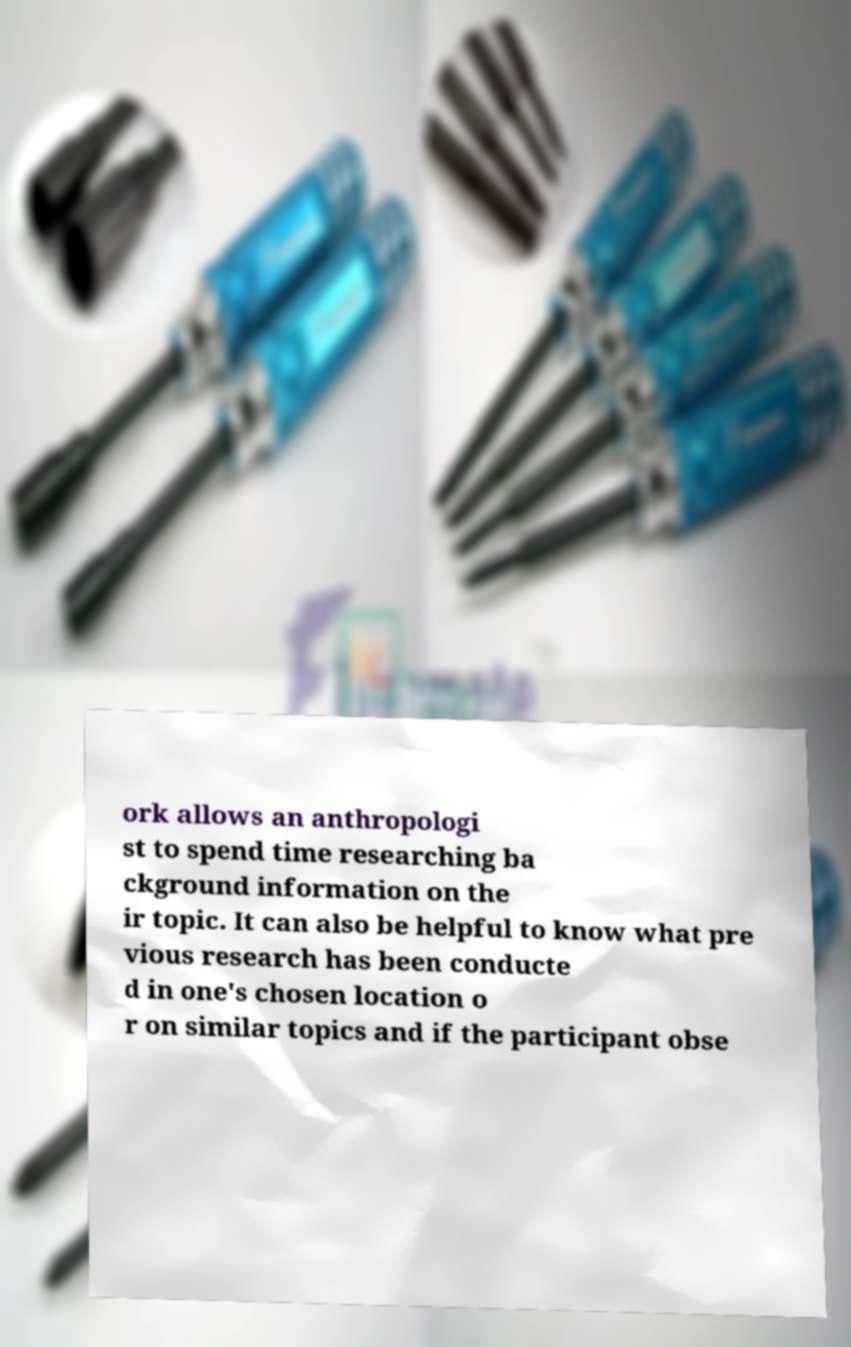Can you read and provide the text displayed in the image?This photo seems to have some interesting text. Can you extract and type it out for me? ork allows an anthropologi st to spend time researching ba ckground information on the ir topic. It can also be helpful to know what pre vious research has been conducte d in one's chosen location o r on similar topics and if the participant obse 